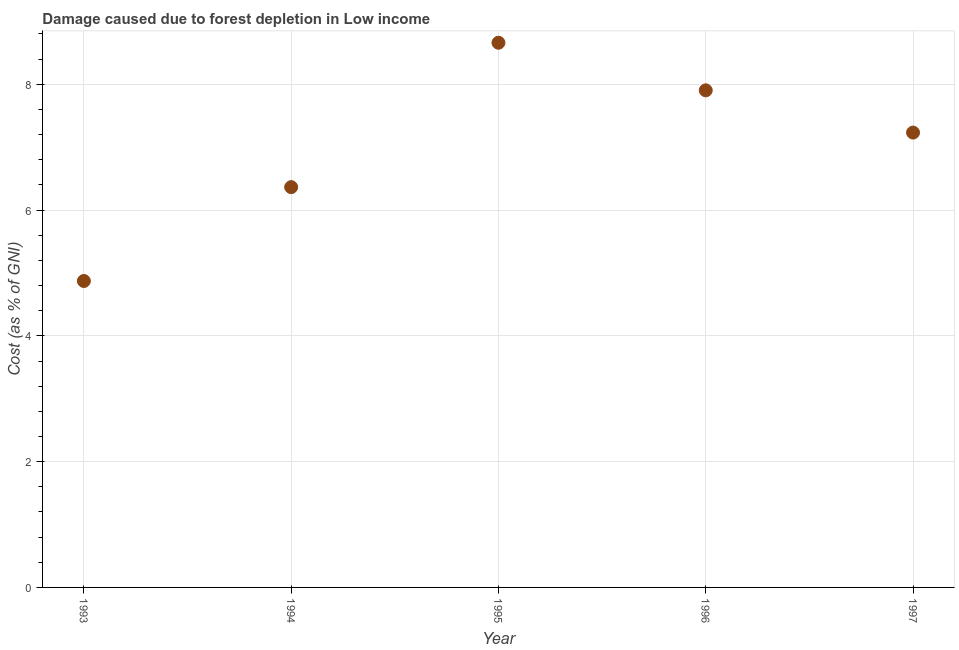What is the damage caused due to forest depletion in 1993?
Give a very brief answer. 4.87. Across all years, what is the maximum damage caused due to forest depletion?
Keep it short and to the point. 8.66. Across all years, what is the minimum damage caused due to forest depletion?
Make the answer very short. 4.87. What is the sum of the damage caused due to forest depletion?
Provide a succinct answer. 35.03. What is the difference between the damage caused due to forest depletion in 1994 and 1997?
Offer a terse response. -0.87. What is the average damage caused due to forest depletion per year?
Offer a terse response. 7.01. What is the median damage caused due to forest depletion?
Provide a short and direct response. 7.23. In how many years, is the damage caused due to forest depletion greater than 0.4 %?
Offer a very short reply. 5. Do a majority of the years between 1993 and 1994 (inclusive) have damage caused due to forest depletion greater than 2.4 %?
Your response must be concise. Yes. What is the ratio of the damage caused due to forest depletion in 1996 to that in 1997?
Make the answer very short. 1.09. Is the difference between the damage caused due to forest depletion in 1995 and 1997 greater than the difference between any two years?
Ensure brevity in your answer.  No. What is the difference between the highest and the second highest damage caused due to forest depletion?
Your response must be concise. 0.76. Is the sum of the damage caused due to forest depletion in 1993 and 1996 greater than the maximum damage caused due to forest depletion across all years?
Provide a short and direct response. Yes. What is the difference between the highest and the lowest damage caused due to forest depletion?
Offer a terse response. 3.79. What is the difference between two consecutive major ticks on the Y-axis?
Your response must be concise. 2. Does the graph contain grids?
Provide a succinct answer. Yes. What is the title of the graph?
Ensure brevity in your answer.  Damage caused due to forest depletion in Low income. What is the label or title of the X-axis?
Your answer should be compact. Year. What is the label or title of the Y-axis?
Provide a succinct answer. Cost (as % of GNI). What is the Cost (as % of GNI) in 1993?
Your answer should be compact. 4.87. What is the Cost (as % of GNI) in 1994?
Your response must be concise. 6.36. What is the Cost (as % of GNI) in 1995?
Your answer should be compact. 8.66. What is the Cost (as % of GNI) in 1996?
Give a very brief answer. 7.9. What is the Cost (as % of GNI) in 1997?
Ensure brevity in your answer.  7.23. What is the difference between the Cost (as % of GNI) in 1993 and 1994?
Your response must be concise. -1.49. What is the difference between the Cost (as % of GNI) in 1993 and 1995?
Offer a very short reply. -3.79. What is the difference between the Cost (as % of GNI) in 1993 and 1996?
Keep it short and to the point. -3.03. What is the difference between the Cost (as % of GNI) in 1993 and 1997?
Make the answer very short. -2.36. What is the difference between the Cost (as % of GNI) in 1994 and 1995?
Give a very brief answer. -2.3. What is the difference between the Cost (as % of GNI) in 1994 and 1996?
Offer a very short reply. -1.54. What is the difference between the Cost (as % of GNI) in 1994 and 1997?
Give a very brief answer. -0.87. What is the difference between the Cost (as % of GNI) in 1995 and 1996?
Keep it short and to the point. 0.76. What is the difference between the Cost (as % of GNI) in 1995 and 1997?
Ensure brevity in your answer.  1.43. What is the difference between the Cost (as % of GNI) in 1996 and 1997?
Make the answer very short. 0.67. What is the ratio of the Cost (as % of GNI) in 1993 to that in 1994?
Provide a succinct answer. 0.77. What is the ratio of the Cost (as % of GNI) in 1993 to that in 1995?
Offer a terse response. 0.56. What is the ratio of the Cost (as % of GNI) in 1993 to that in 1996?
Offer a very short reply. 0.62. What is the ratio of the Cost (as % of GNI) in 1993 to that in 1997?
Give a very brief answer. 0.67. What is the ratio of the Cost (as % of GNI) in 1994 to that in 1995?
Your answer should be compact. 0.73. What is the ratio of the Cost (as % of GNI) in 1994 to that in 1996?
Provide a short and direct response. 0.81. What is the ratio of the Cost (as % of GNI) in 1994 to that in 1997?
Keep it short and to the point. 0.88. What is the ratio of the Cost (as % of GNI) in 1995 to that in 1996?
Make the answer very short. 1.1. What is the ratio of the Cost (as % of GNI) in 1995 to that in 1997?
Make the answer very short. 1.2. What is the ratio of the Cost (as % of GNI) in 1996 to that in 1997?
Your answer should be very brief. 1.09. 